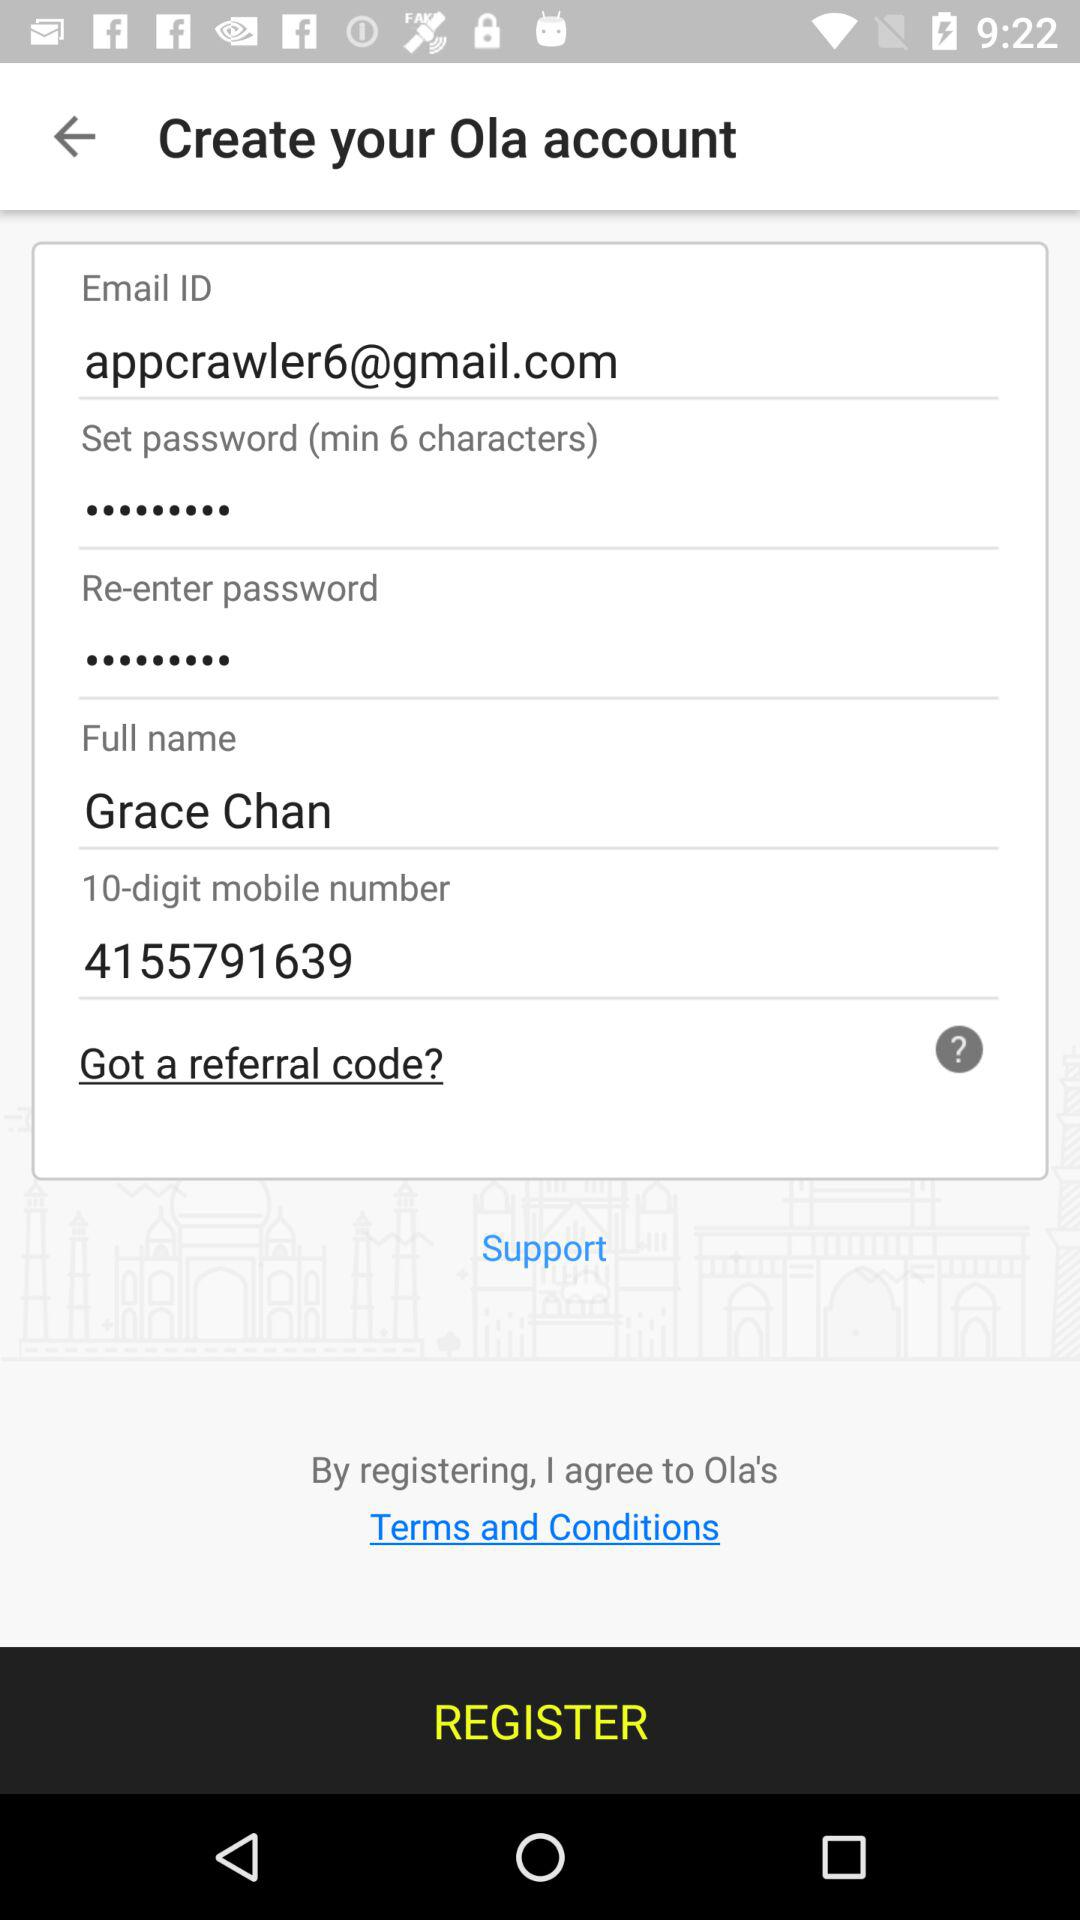What is the email address? The email address is appcrawler6@gmail.com. 